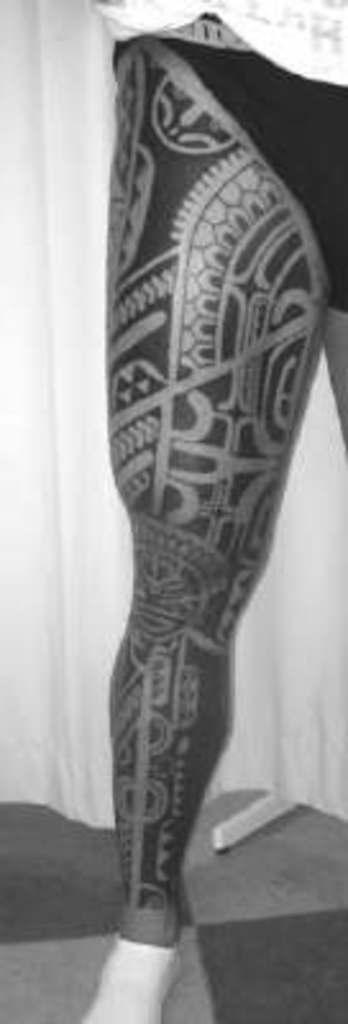What part of the body is visible in the image? There is a person's leg in the image. What feature can be seen on the leg? The leg has a tattoo. What is behind the leg in the image? There is a cloth behind the leg. What type of leather is visible on the person's leg in the image? There is no leather visible on the person's leg in the image; it only shows a tattooed leg with a cloth behind it. 